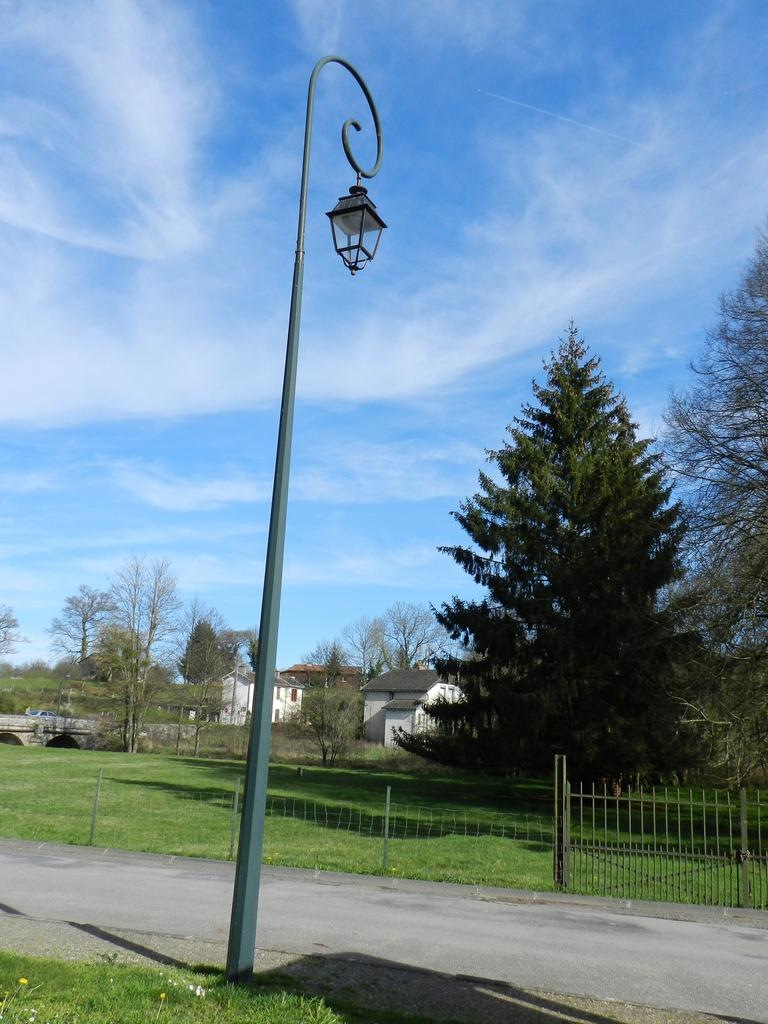What structure can be seen in the image? There is a light pole in the image. What can be seen in the background of the image? There is a railing, trees with green color, and buildings in the background of the image. What is the color of the sky in the image? The sky is blue and white in color. What type of butter is being used to paint the railing in the image? There is no butter present in the image, and the railing is not being painted. 